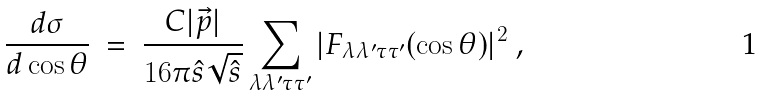<formula> <loc_0><loc_0><loc_500><loc_500>\frac { d \sigma } { d \cos \theta } \ = \ \frac { C | \vec { p } | } { 1 6 \pi \hat { s } \sqrt { \hat { s } } } \sum _ { \lambda \lambda ^ { \prime } \tau \tau ^ { \prime } } | F _ { \lambda \lambda ^ { \prime } \tau \tau ^ { \prime } } ( \cos \theta ) | ^ { 2 } \ ,</formula> 